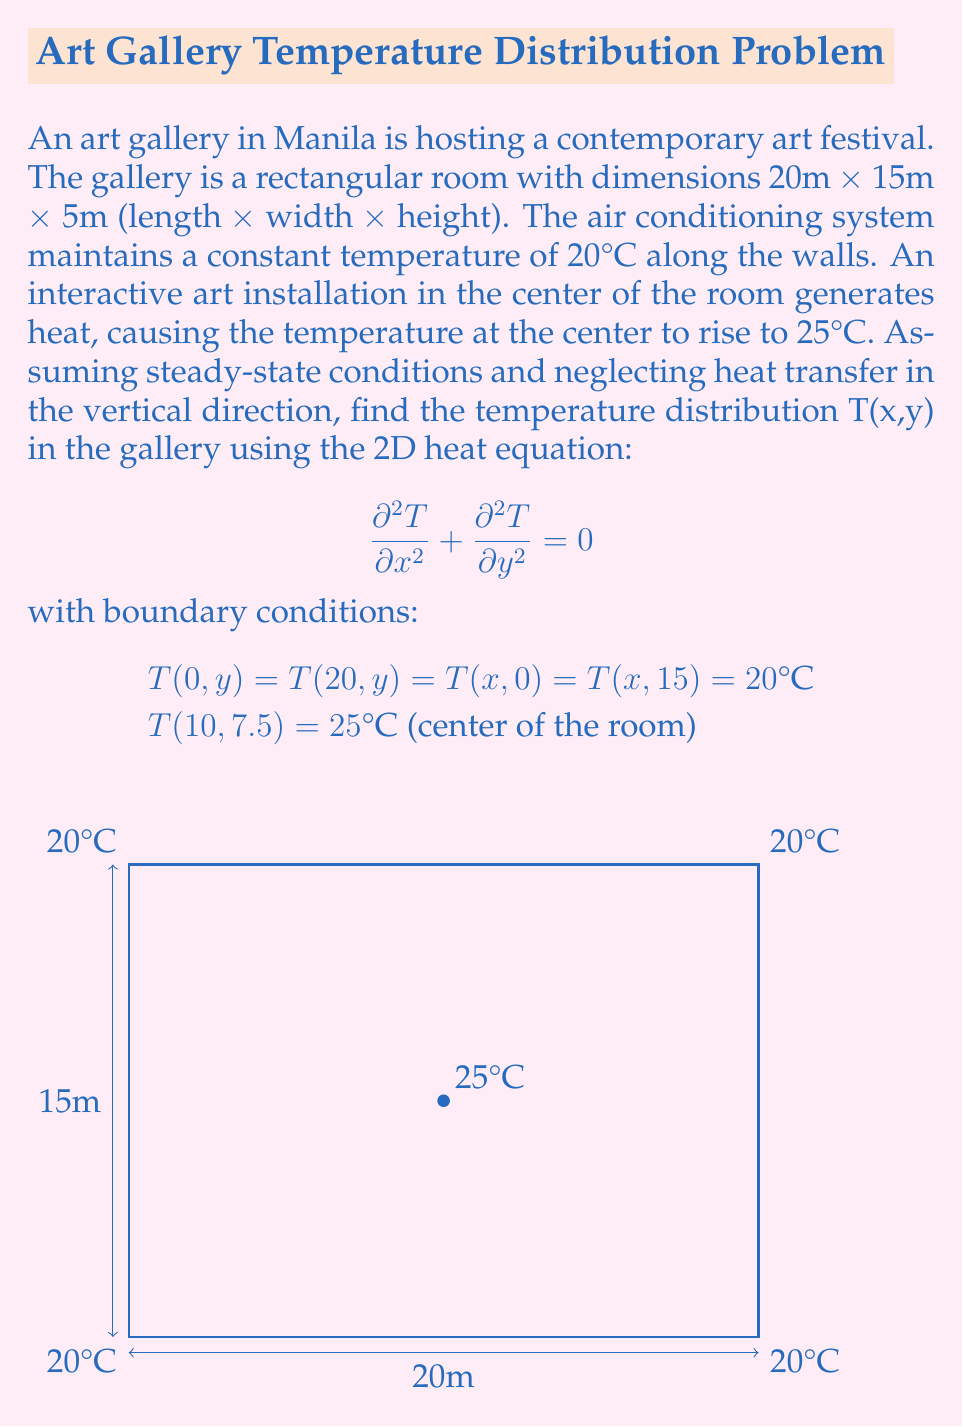Teach me how to tackle this problem. To solve this problem, we'll use the method of separation of variables:

1) Assume the solution has the form: $T(x,y) = X(x)Y(y)$

2) Substituting into the heat equation:
   $$ X''(x)Y(y) + X(x)Y''(y) = 0 $$
   $$ \frac{X''(x)}{X(x)} = -\frac{Y''(y)}{Y(y)} = -\lambda^2 $$

3) This gives us two ODEs:
   $$ X''(x) + \lambda^2 X(x) = 0 $$
   $$ Y''(y) + \lambda^2 Y(y) = 0 $$

4) The general solutions are:
   $$ X(x) = A \cos(\lambda x) + B \sin(\lambda x) $$
   $$ Y(y) = C \cos(\lambda y) + D \sin(\lambda y) $$

5) Applying boundary conditions:
   T(0,y) = T(20,y) = 20 implies $\lambda_n = \frac{n\pi}{20}$, where n is an odd integer.
   T(x,0) = T(x,15) = 20 implies $\lambda_m = \frac{m\pi}{15}$, where m is an odd integer.

6) The solution that satisfies all boundary conditions except the center point is:
   $$ T(x,y) = 20 + \sum_{n,m \text{ odd}} a_{nm} \sin(\frac{n\pi x}{20}) \sin(\frac{m\pi y}{15}) $$

7) To satisfy T(10,7.5) = 25, we need to determine the coefficients $a_{nm}$:
   $$ 5 = \sum_{n,m \text{ odd}} a_{nm} \sin(\frac{n\pi}{2}) \sin(\frac{m\pi}{2}) $$

8) This is an infinite system of equations. In practice, we'd truncate the series and solve numerically for the coefficients $a_{nm}$.
Answer: $T(x,y) = 20 + \sum_{n,m \text{ odd}} a_{nm} \sin(\frac{n\pi x}{20}) \sin(\frac{m\pi y}{15})$, where $a_{nm}$ are determined numerically. 